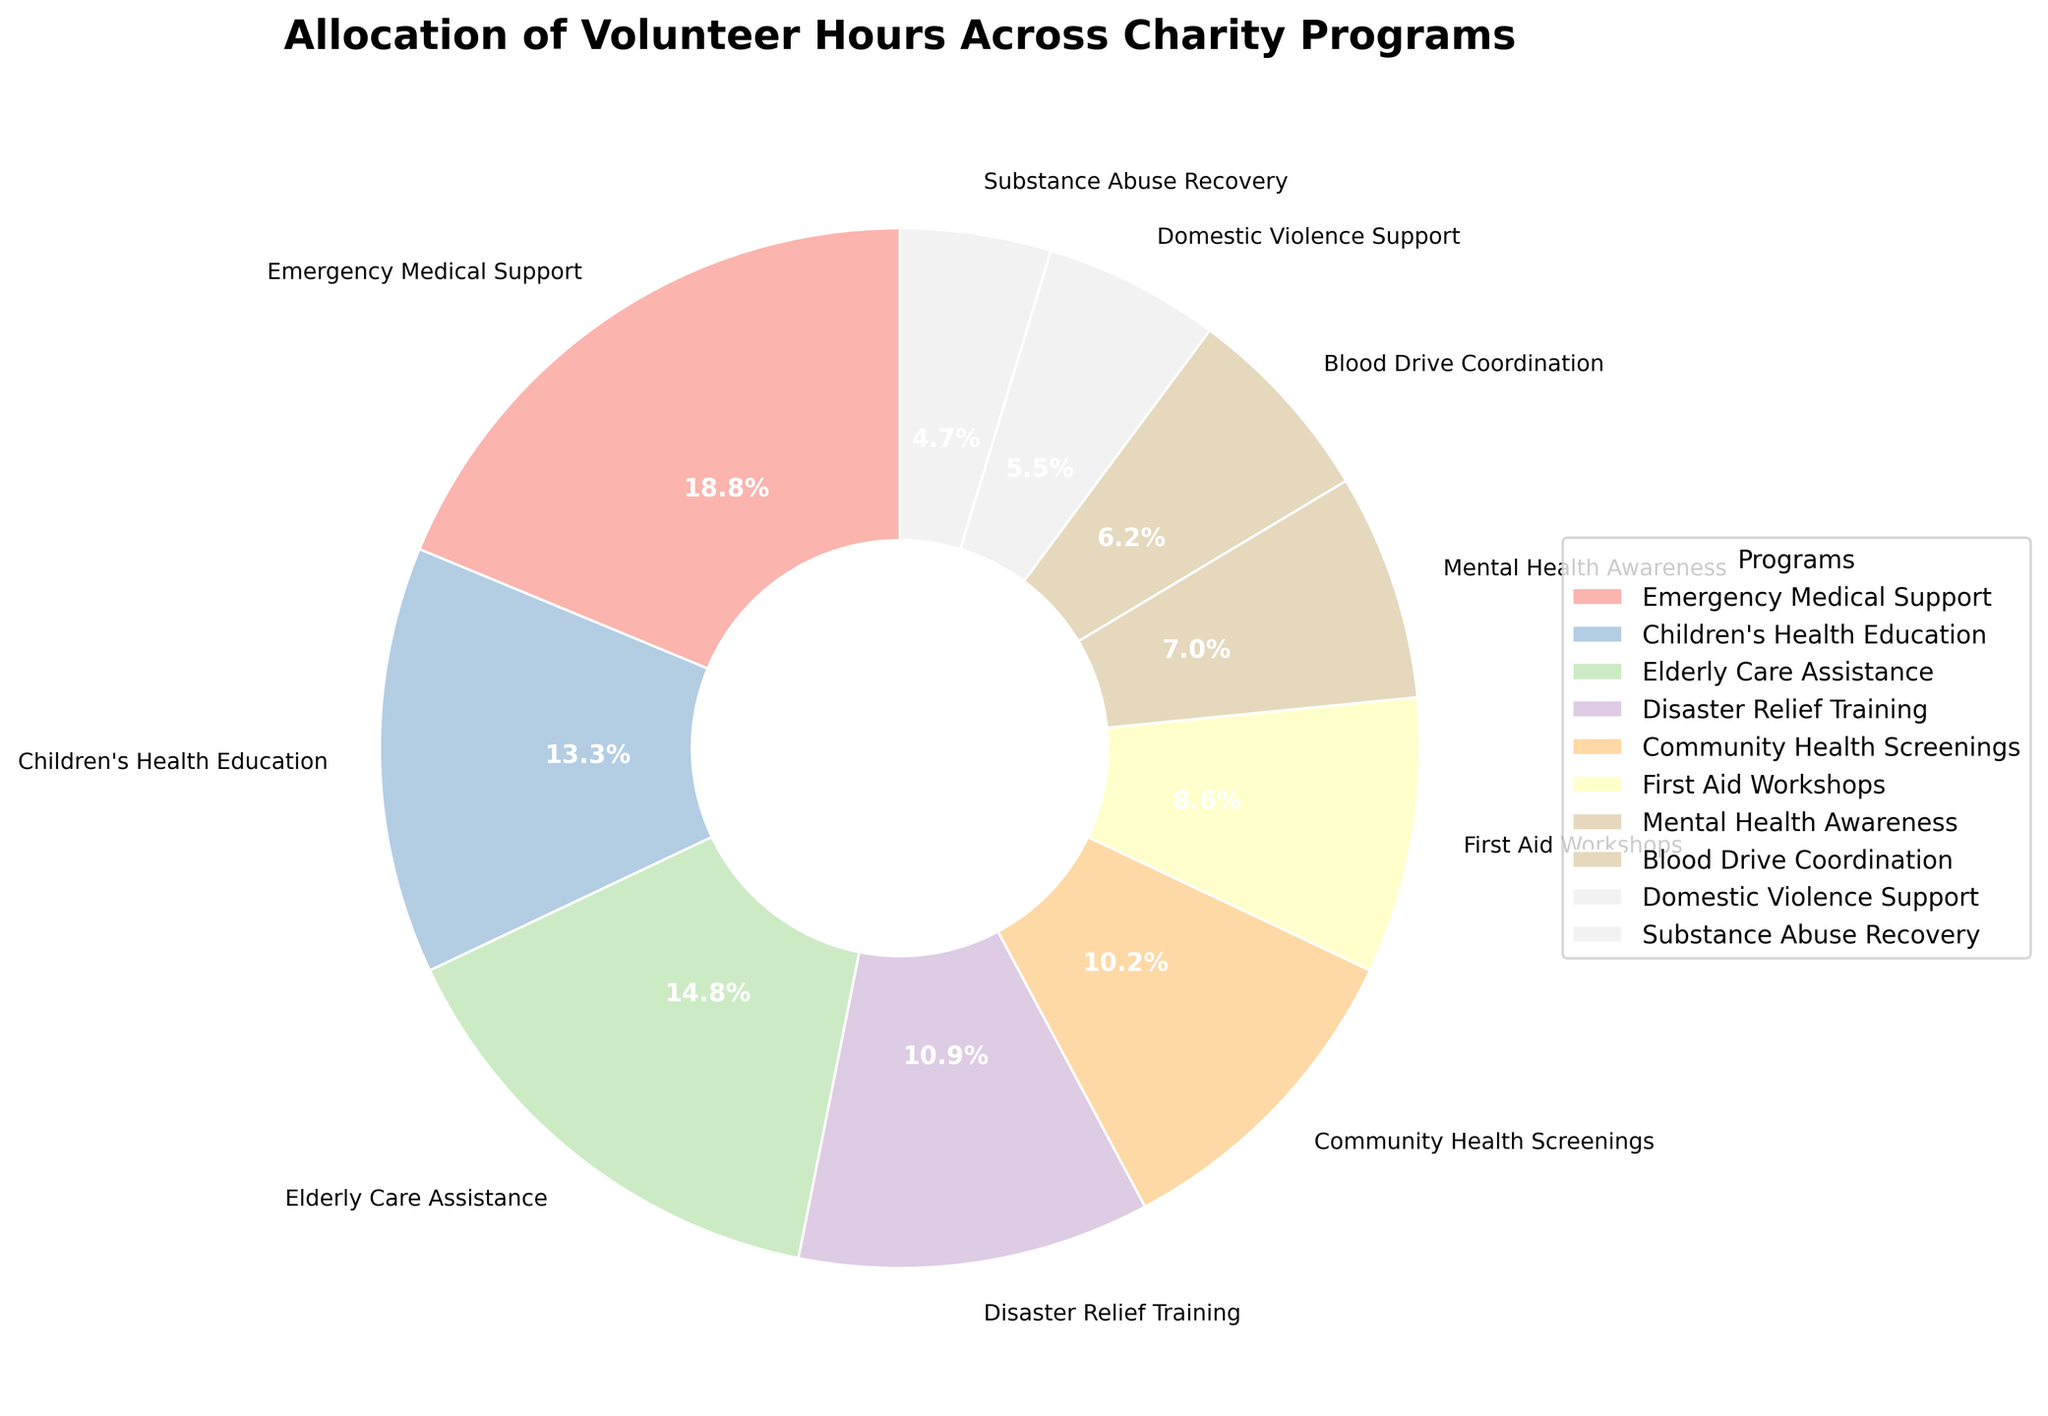Which program receives the highest allocation of volunteer hours? By examining the pie chart, the biggest slice corresponds to the program with the highest allocation of hours. The "Emergency Medical Support" program has the largest slice.
Answer: Emergency Medical Support What percentage of volunteer hours is allocated to Community Health Screenings? The pie chart segment labeled "Community Health Screenings" shows the percentage directly on the plot, which is 10.4%.
Answer: 10.4% Which program has more volunteer hours allocated, Elderly Care Assistance or Disaster Relief Training? By comparing the sizes of the corresponding slices, "Elderly Care Assistance" has a larger slice than "Disaster Relief Training," indicating more hours.
Answer: Elderly Care Assistance How many hours are allocated to programs related to medical support and awareness collectively? We sum up the hours for the programs "Emergency Medical Support" (120), "First Aid Workshops" (55), and "Blood Drive Coordination" (40) to get the total: 120 + 55 + 40 = 215.
Answer: 215 What is the difference in volunteer hours between the program with the most hours and the program with the least hours? The program with the most hours is "Emergency Medical Support" (120), and the one with the least hours is "Substance Abuse Recovery" (30). The difference is: 120 - 30 = 90.
Answer: 90 Are there any programs with an equal allocation of volunteer hours? By examining the chart, all slices have different sizes. No two programs have the same allocation of volunteer hours.
Answer: No Which program represents the smallest percentage of the total volunteer hours? The smallest slice in the pie chart represents the "Substance Abuse Recovery" program.
Answer: Substance Abuse Recovery What color is used to represent the First Aid Workshops program in the pie chart? By looking at the pie chart, the "First Aid Workshops" slice is represented by a particular color from the pastel color palette. The exact color can be observed from the chart.
Answer: (exact color representation from visual inspection, e.g., light pink) How much more or less volunteer hours does Domestic Violence Support have compared to Mental Health Awareness? By looking at the slices, "Domestic Violence Support" has 35 hours and "Mental Health Awareness" has 45 hours. The difference is: 45 - 35 = 10.
Answer: 10 What is the average number of volunteer hours allocated to each program? There are ten programs, and the total volunteer hours are the sum of all the hours given: 120 + 85 + 95 + 70 + 65 + 55 + 45 + 40 + 35 + 30 = 640. Therefore, the average is 640 / 10 = 64.
Answer: 64 